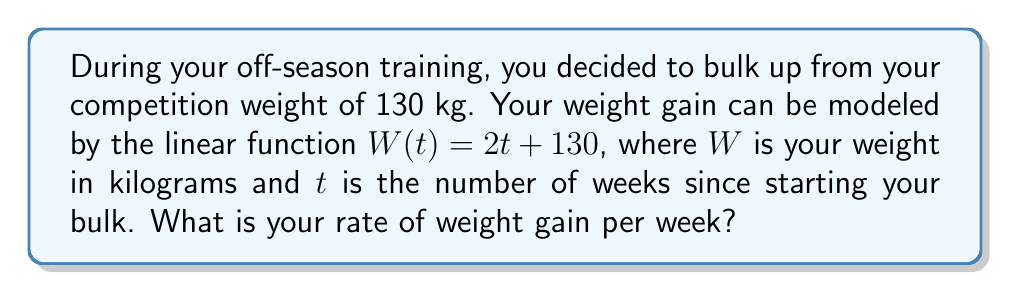What is the answer to this math problem? To find the rate of weight gain, we need to analyze the given linear function:

$W(t) = 2t + 130$

In a linear function of the form $y = mx + b$, the coefficient $m$ represents the slope of the line, which is the rate of change of $y$ with respect to $x$.

In this case:
- $W$ (weight) is our $y$ variable
- $t$ (time in weeks) is our $x$ variable
- The function is in the form $W = 2t + 130$

Comparing this to the standard form $y = mx + b$:
- $m = 2$
- $b = 130$

The slope $m = 2$ represents the rate of change of weight with respect to time. This means that for each unit increase in $t$ (each week), $W$ (weight) increases by 2 units (kilograms).

Therefore, the rate of weight gain is 2 kilograms per week.
Answer: 2 kg/week 